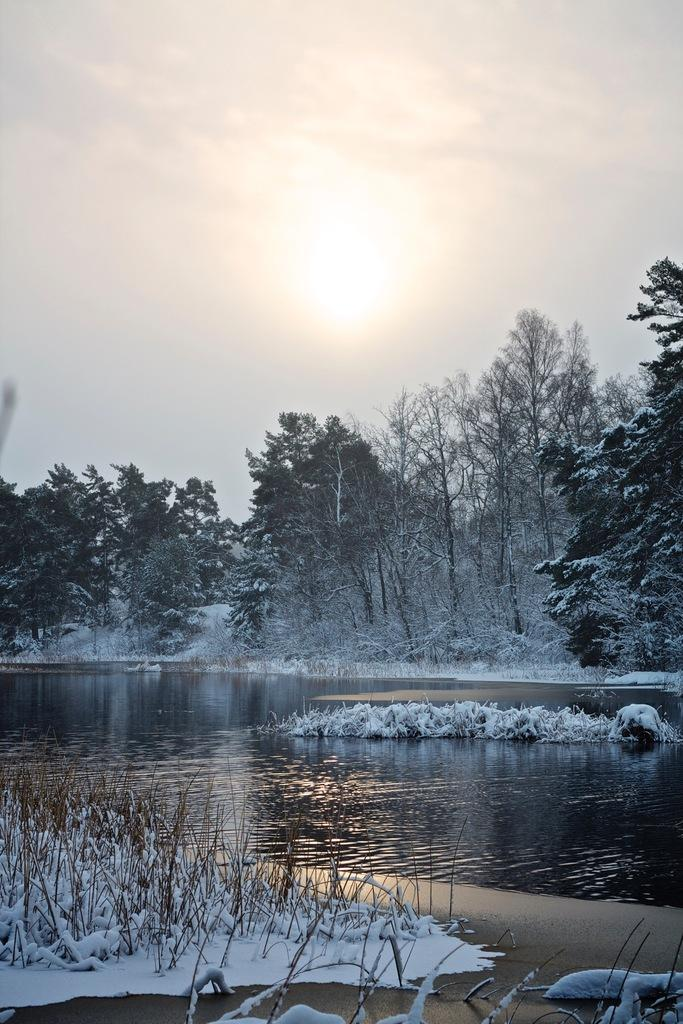What type of plants can be seen in the image? There are dry plants in the image. What else is visible in the image besides the plants? There is water visible in the image. What is the condition of the trees in the image? Trees covered with snow are present in the image. How would you describe the weather based on the sky in the image? The sky in the background is sunny. What type of coach is driving through the image? There is no coach present in the image. What rhythm can be heard in the image? The image is a still picture, so there is no sound or rhythm present. 